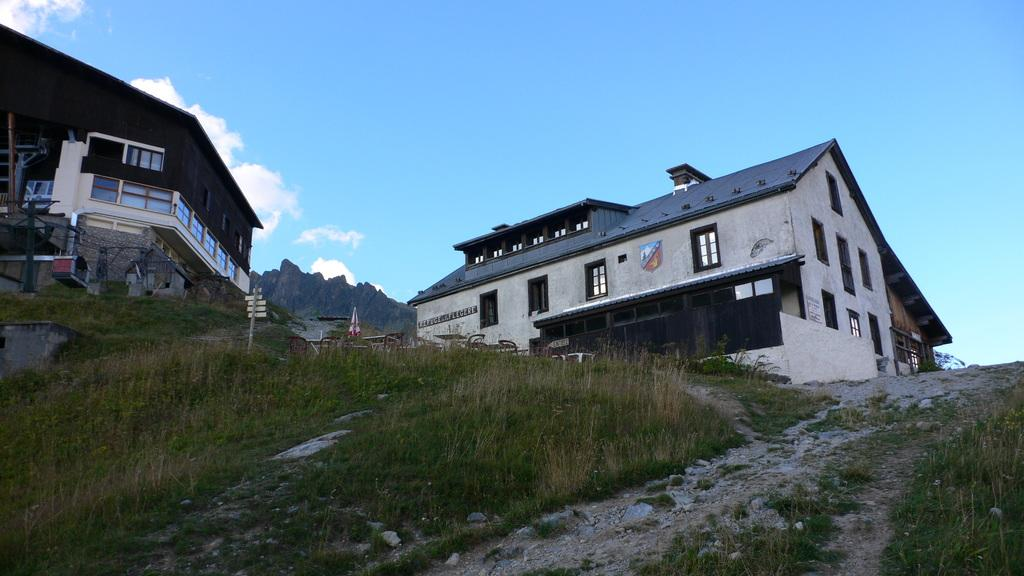What type of structures are visible in the image? There are buildings with windows in the image. What type of vegetation is present in the image? There is grass in the image. What object is present for providing shade or protection from the rain? There is an umbrella in the image. What geographical feature can be seen in the image? There is a mountain in the image. What is visible in the background of the image? The sky with clouds is visible in the background of the image. Can you tell me how many times the person jumps in the image? There is no person present in the image, and therefore no jumping can be observed. What type of ocean can be seen in the image? There is no ocean present in the image; it features a mountain, buildings, grass, and an umbrella. 